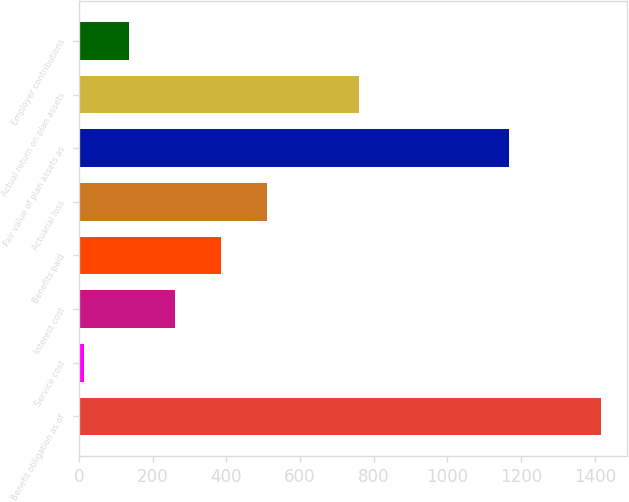Convert chart. <chart><loc_0><loc_0><loc_500><loc_500><bar_chart><fcel>Benefit obligation as of<fcel>Service cost<fcel>Interest cost<fcel>Benefits paid<fcel>Actuarial loss<fcel>Fair value of plan assets as<fcel>Actual return on plan assets<fcel>Employer contributions<nl><fcel>1417.2<fcel>13<fcel>261.8<fcel>386.2<fcel>510.6<fcel>1168.4<fcel>759.4<fcel>137.4<nl></chart> 